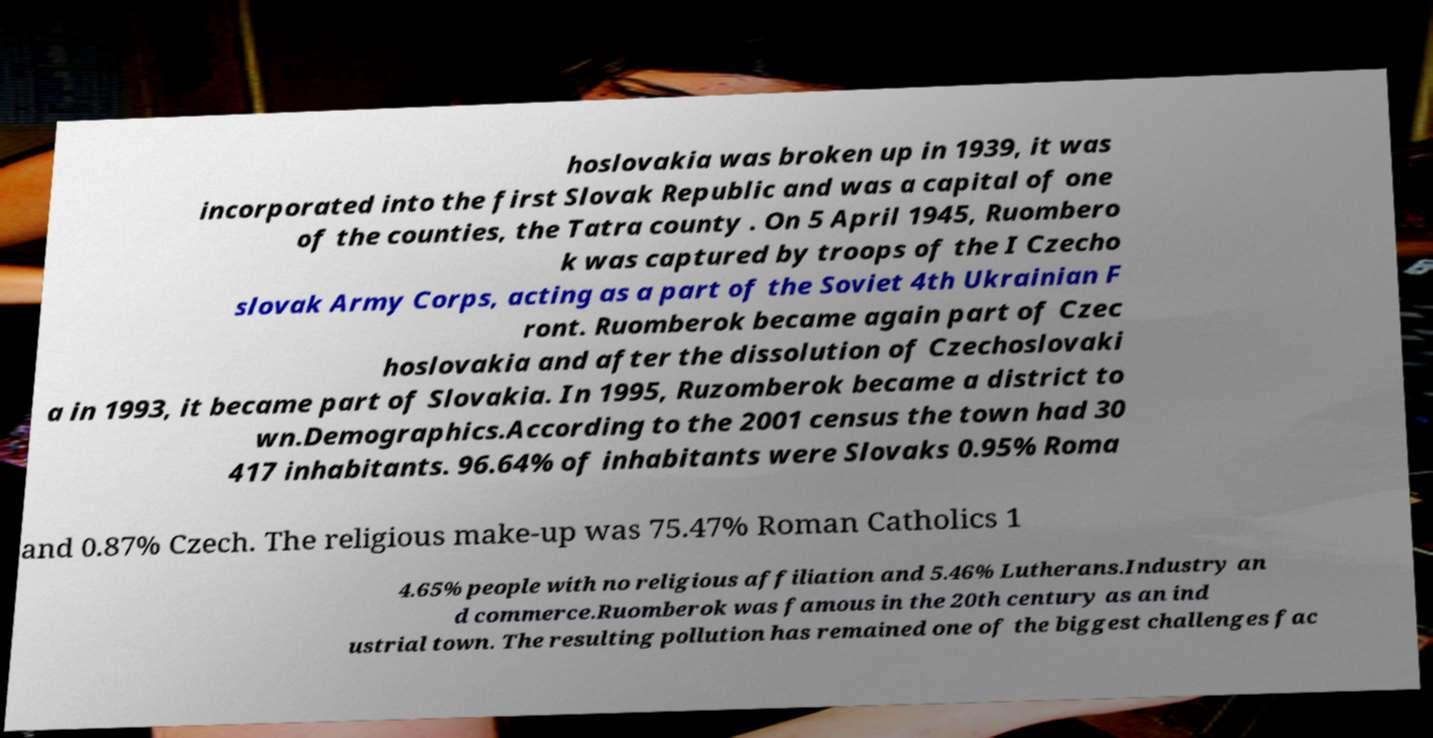Please read and relay the text visible in this image. What does it say? hoslovakia was broken up in 1939, it was incorporated into the first Slovak Republic and was a capital of one of the counties, the Tatra county . On 5 April 1945, Ruombero k was captured by troops of the I Czecho slovak Army Corps, acting as a part of the Soviet 4th Ukrainian F ront. Ruomberok became again part of Czec hoslovakia and after the dissolution of Czechoslovaki a in 1993, it became part of Slovakia. In 1995, Ruzomberok became a district to wn.Demographics.According to the 2001 census the town had 30 417 inhabitants. 96.64% of inhabitants were Slovaks 0.95% Roma and 0.87% Czech. The religious make-up was 75.47% Roman Catholics 1 4.65% people with no religious affiliation and 5.46% Lutherans.Industry an d commerce.Ruomberok was famous in the 20th century as an ind ustrial town. The resulting pollution has remained one of the biggest challenges fac 